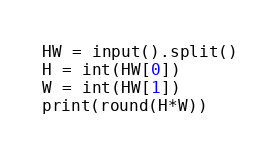<code> <loc_0><loc_0><loc_500><loc_500><_Python_>HW = input().split()
H = int(HW[0])
W = int(HW[1])
print(round(H*W))</code> 